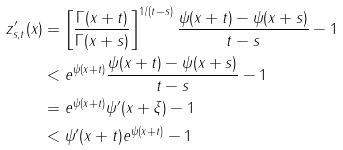Convert formula to latex. <formula><loc_0><loc_0><loc_500><loc_500>z ^ { \prime } _ { s , t } ( x ) & = \left [ \frac { \Gamma ( x + t ) } { \Gamma ( x + s ) } \right ] ^ { 1 / ( t - s ) } \frac { \psi ( x + t ) - \psi ( x + s ) } { t - s } - 1 \\ & < e ^ { \psi ( x + t ) } \frac { \psi ( x + t ) - \psi ( x + s ) } { t - s } - 1 \\ & = e ^ { \psi ( x + t ) } \psi ^ { \prime } ( x + \xi ) - 1 \\ & < \psi ^ { \prime } ( x + t ) e ^ { \psi ( x + t ) } - 1</formula> 